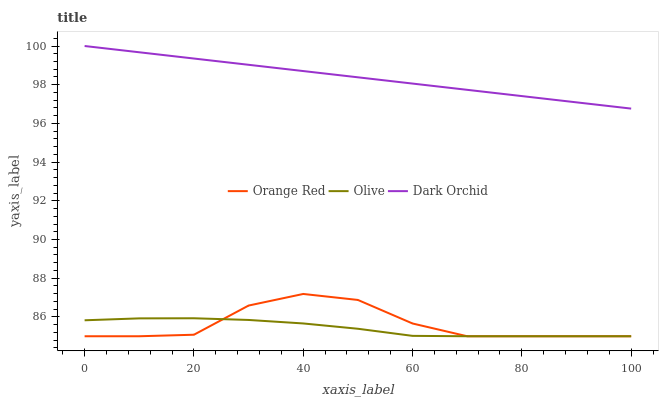Does Olive have the minimum area under the curve?
Answer yes or no. Yes. Does Dark Orchid have the maximum area under the curve?
Answer yes or no. Yes. Does Orange Red have the minimum area under the curve?
Answer yes or no. No. Does Orange Red have the maximum area under the curve?
Answer yes or no. No. Is Dark Orchid the smoothest?
Answer yes or no. Yes. Is Orange Red the roughest?
Answer yes or no. Yes. Is Orange Red the smoothest?
Answer yes or no. No. Is Dark Orchid the roughest?
Answer yes or no. No. Does Olive have the lowest value?
Answer yes or no. Yes. Does Dark Orchid have the lowest value?
Answer yes or no. No. Does Dark Orchid have the highest value?
Answer yes or no. Yes. Does Orange Red have the highest value?
Answer yes or no. No. Is Olive less than Dark Orchid?
Answer yes or no. Yes. Is Dark Orchid greater than Orange Red?
Answer yes or no. Yes. Does Orange Red intersect Olive?
Answer yes or no. Yes. Is Orange Red less than Olive?
Answer yes or no. No. Is Orange Red greater than Olive?
Answer yes or no. No. Does Olive intersect Dark Orchid?
Answer yes or no. No. 